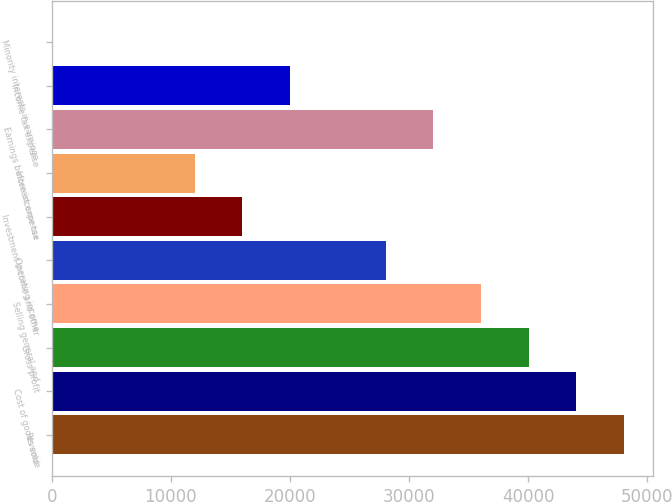Convert chart to OTSL. <chart><loc_0><loc_0><loc_500><loc_500><bar_chart><fcel>Revenue<fcel>Cost of goods sold<fcel>Gross profit<fcel>Selling general and<fcel>Operating income<fcel>Investment income and other<fcel>Interest expense<fcel>Earnings before income tax<fcel>Income tax expense<fcel>Minority interests in earnings<nl><fcel>48027<fcel>44025<fcel>40023<fcel>36021<fcel>28017<fcel>16011<fcel>12009<fcel>32019<fcel>20013<fcel>3<nl></chart> 